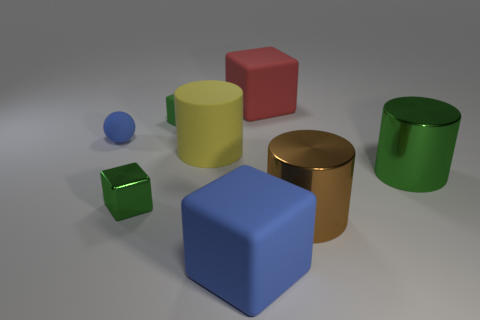Add 1 small rubber things. How many objects exist? 9 Subtract all green blocks. How many blocks are left? 2 Subtract all metallic cylinders. How many cylinders are left? 1 Subtract 0 brown blocks. How many objects are left? 8 Subtract all cylinders. How many objects are left? 5 Subtract 1 cylinders. How many cylinders are left? 2 Subtract all gray cylinders. Subtract all purple spheres. How many cylinders are left? 3 Subtract all green cylinders. How many red balls are left? 0 Subtract all big green matte balls. Subtract all large green shiny objects. How many objects are left? 7 Add 1 large brown shiny objects. How many large brown shiny objects are left? 2 